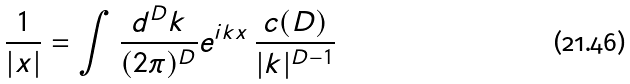<formula> <loc_0><loc_0><loc_500><loc_500>\frac { 1 } { | x | } = \int \frac { d ^ { D } k } { ( 2 \pi ) ^ { D } } e ^ { i k x } \, \frac { c ( D ) } { | { k } | ^ { D - 1 } }</formula> 